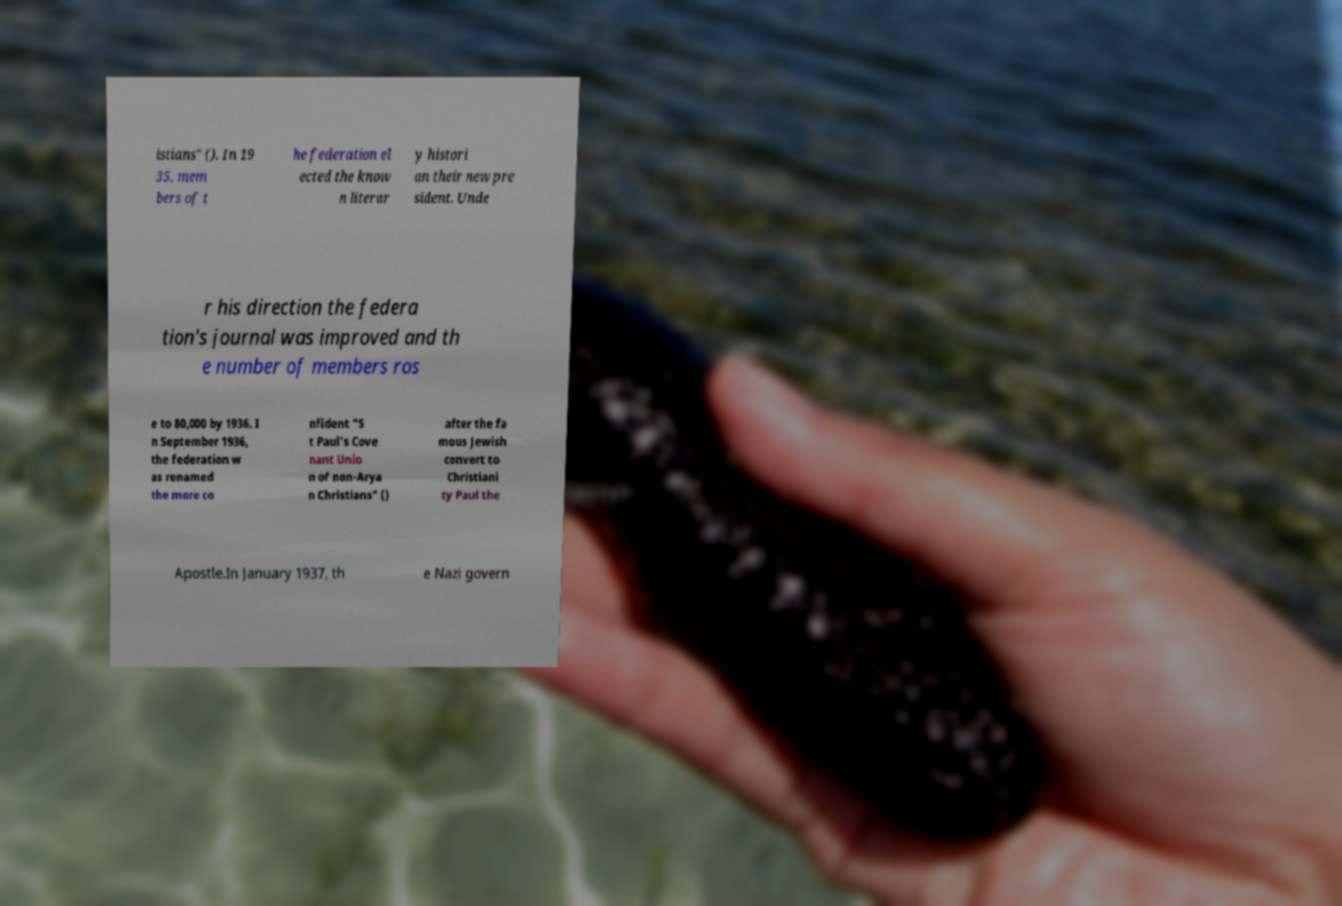Could you assist in decoding the text presented in this image and type it out clearly? istians" (). In 19 35, mem bers of t he federation el ected the know n literar y histori an their new pre sident. Unde r his direction the federa tion's journal was improved and th e number of members ros e to 80,000 by 1936. I n September 1936, the federation w as renamed the more co nfident "S t Paul's Cove nant Unio n of non-Arya n Christians" () after the fa mous Jewish convert to Christiani ty Paul the Apostle.In January 1937, th e Nazi govern 